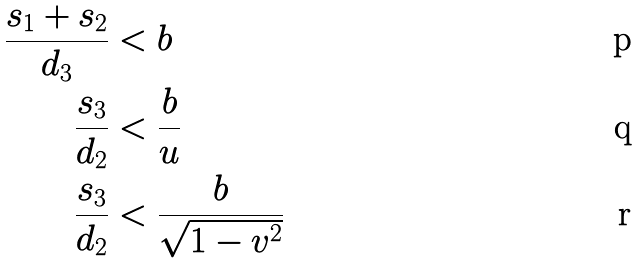<formula> <loc_0><loc_0><loc_500><loc_500>\frac { s _ { 1 } + s _ { 2 } } { d _ { 3 } } & < b \\ \frac { s _ { 3 } } { d _ { 2 } } & < \frac { b } { u } \\ \frac { s _ { 3 } } { d _ { 2 } } & < \frac { b } { \sqrt { 1 - v ^ { 2 } } }</formula> 